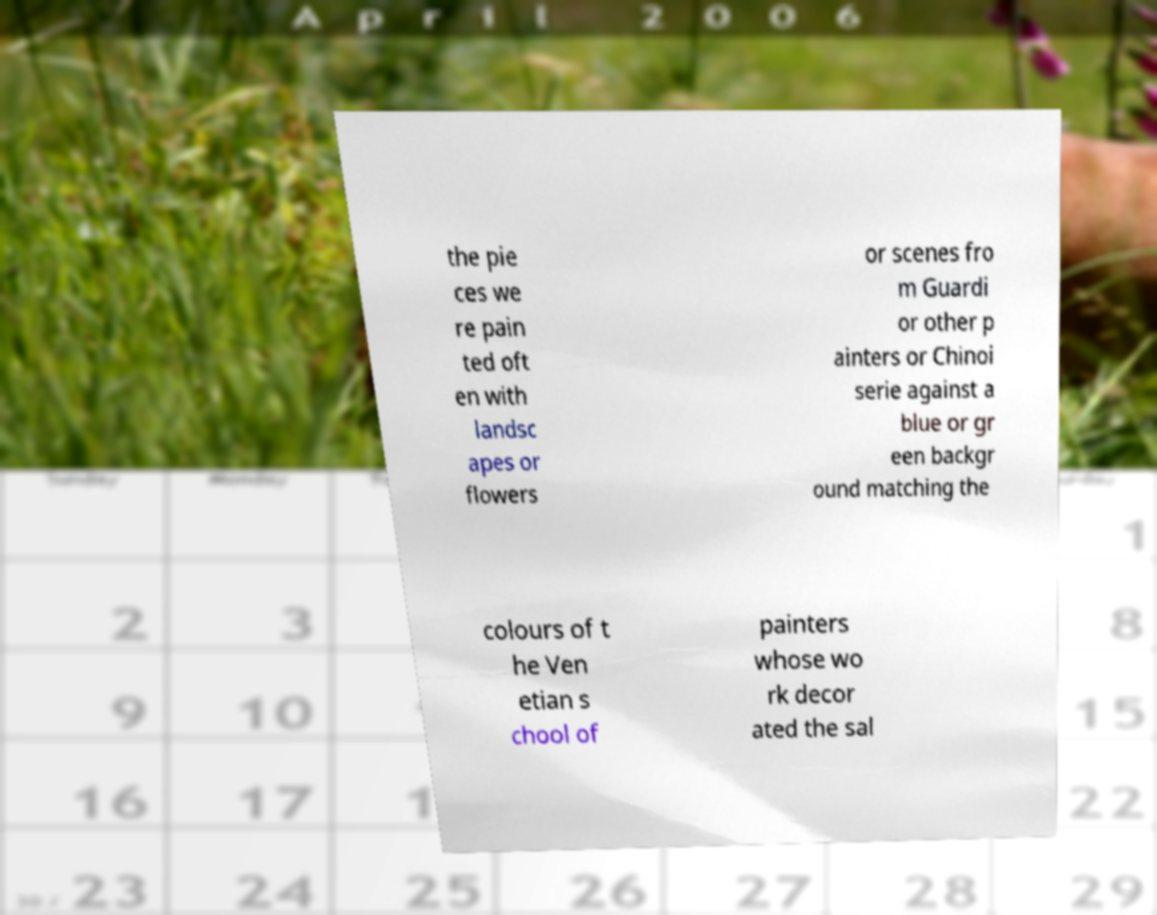Could you assist in decoding the text presented in this image and type it out clearly? the pie ces we re pain ted oft en with landsc apes or flowers or scenes fro m Guardi or other p ainters or Chinoi serie against a blue or gr een backgr ound matching the colours of t he Ven etian s chool of painters whose wo rk decor ated the sal 